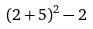Convert formula to latex. <formula><loc_0><loc_0><loc_500><loc_500>( 2 + 5 ) ^ { 2 } - 2</formula> 